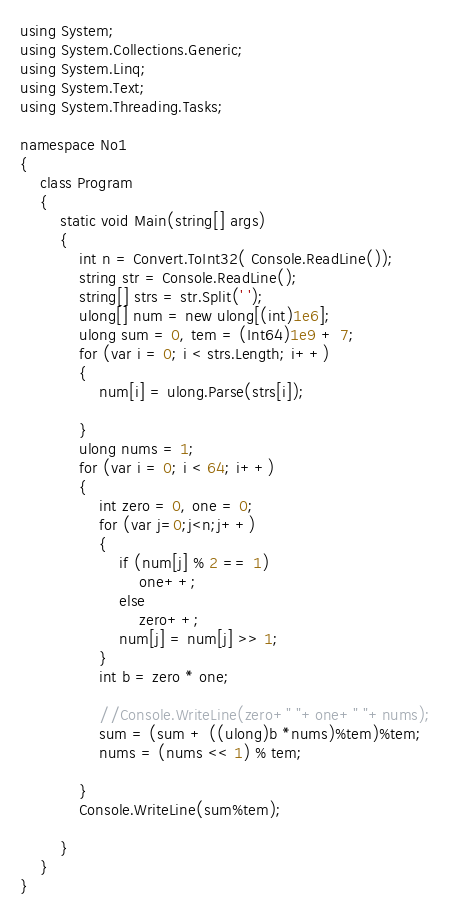<code> <loc_0><loc_0><loc_500><loc_500><_C#_>using System;
using System.Collections.Generic;
using System.Linq;
using System.Text;
using System.Threading.Tasks;

namespace No1
{
    class Program
    {
        static void Main(string[] args)
        {
            int n = Convert.ToInt32( Console.ReadLine());
            string str = Console.ReadLine();
            string[] strs = str.Split(' ');
            ulong[] num = new ulong[(int)1e6];
            ulong sum = 0, tem = (Int64)1e9 + 7;
            for (var i = 0; i < strs.Length; i++)
            {
                num[i] = ulong.Parse(strs[i]);
               
            }
            ulong nums = 1;
            for (var i = 0; i < 64; i++)
            {
                int zero = 0, one = 0;
                for (var j=0;j<n;j++)
                {
                    if (num[j] % 2 == 1)
                        one++;
                    else
                        zero++;
                    num[j] = num[j] >> 1;
                }
                int b = zero * one;
                
                //Console.WriteLine(zero+" "+one+" "+nums);
                sum = (sum + ((ulong)b *nums)%tem)%tem;
                nums = (nums << 1) % tem;

            }
            Console.WriteLine(sum%tem);

        }
    }
}
</code> 